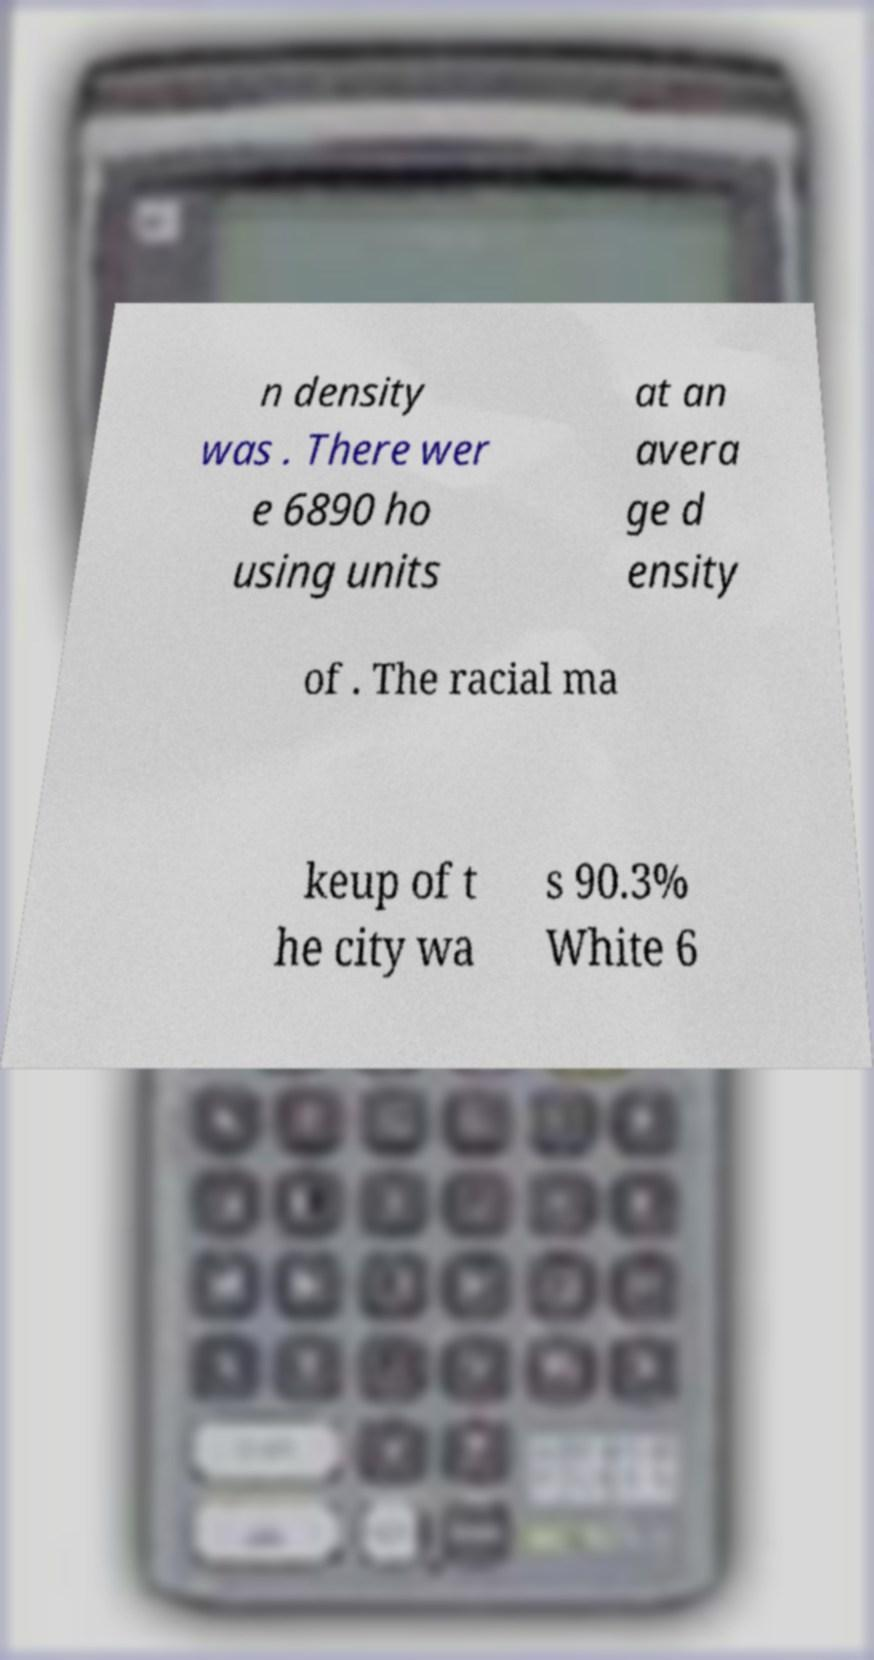Please identify and transcribe the text found in this image. n density was . There wer e 6890 ho using units at an avera ge d ensity of . The racial ma keup of t he city wa s 90.3% White 6 